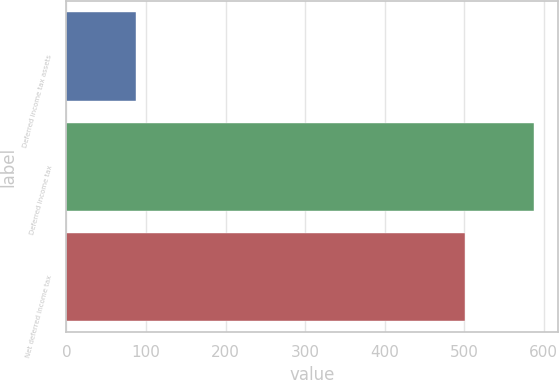<chart> <loc_0><loc_0><loc_500><loc_500><bar_chart><fcel>Deferred income tax assets<fcel>Deferred income tax<fcel>Net deferred income tax<nl><fcel>87<fcel>588<fcel>501<nl></chart> 